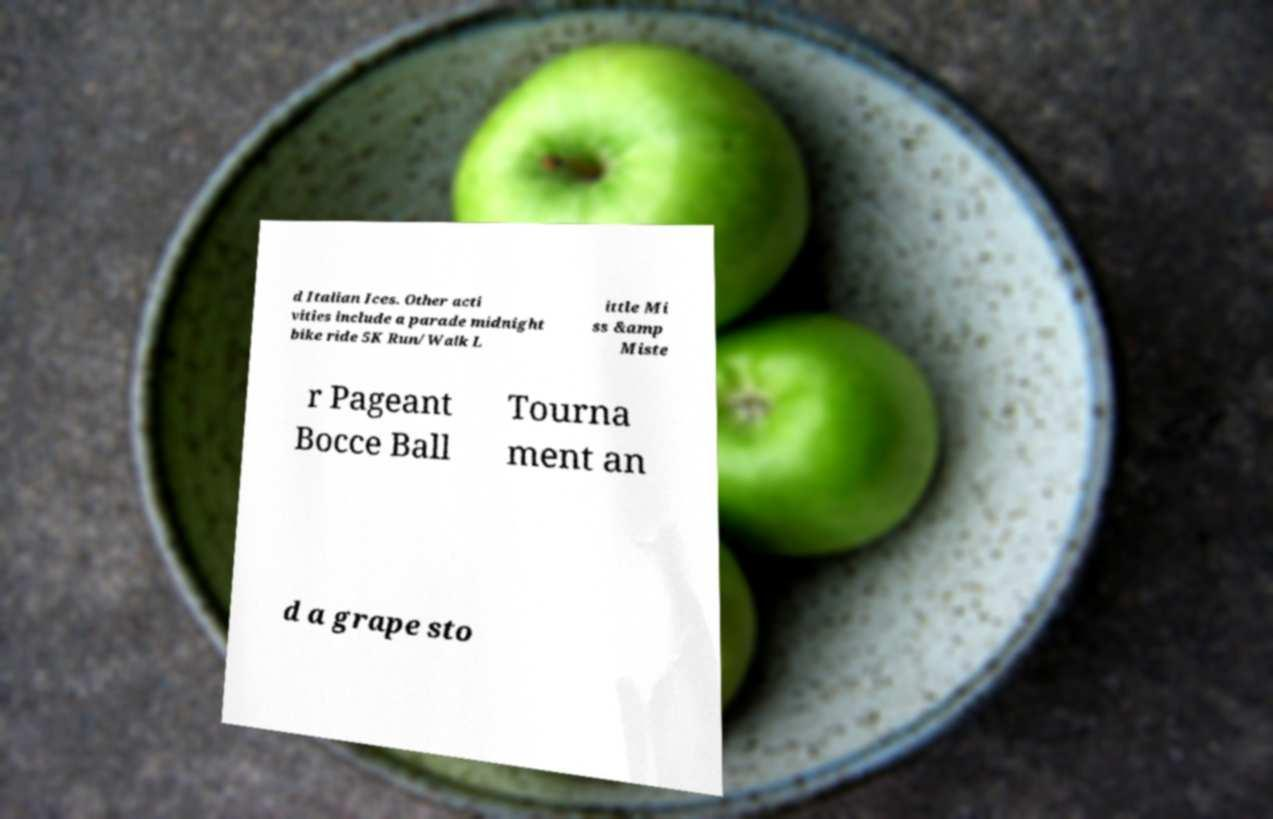Can you read and provide the text displayed in the image?This photo seems to have some interesting text. Can you extract and type it out for me? d Italian Ices. Other acti vities include a parade midnight bike ride 5K Run/Walk L ittle Mi ss &amp Miste r Pageant Bocce Ball Tourna ment an d a grape sto 